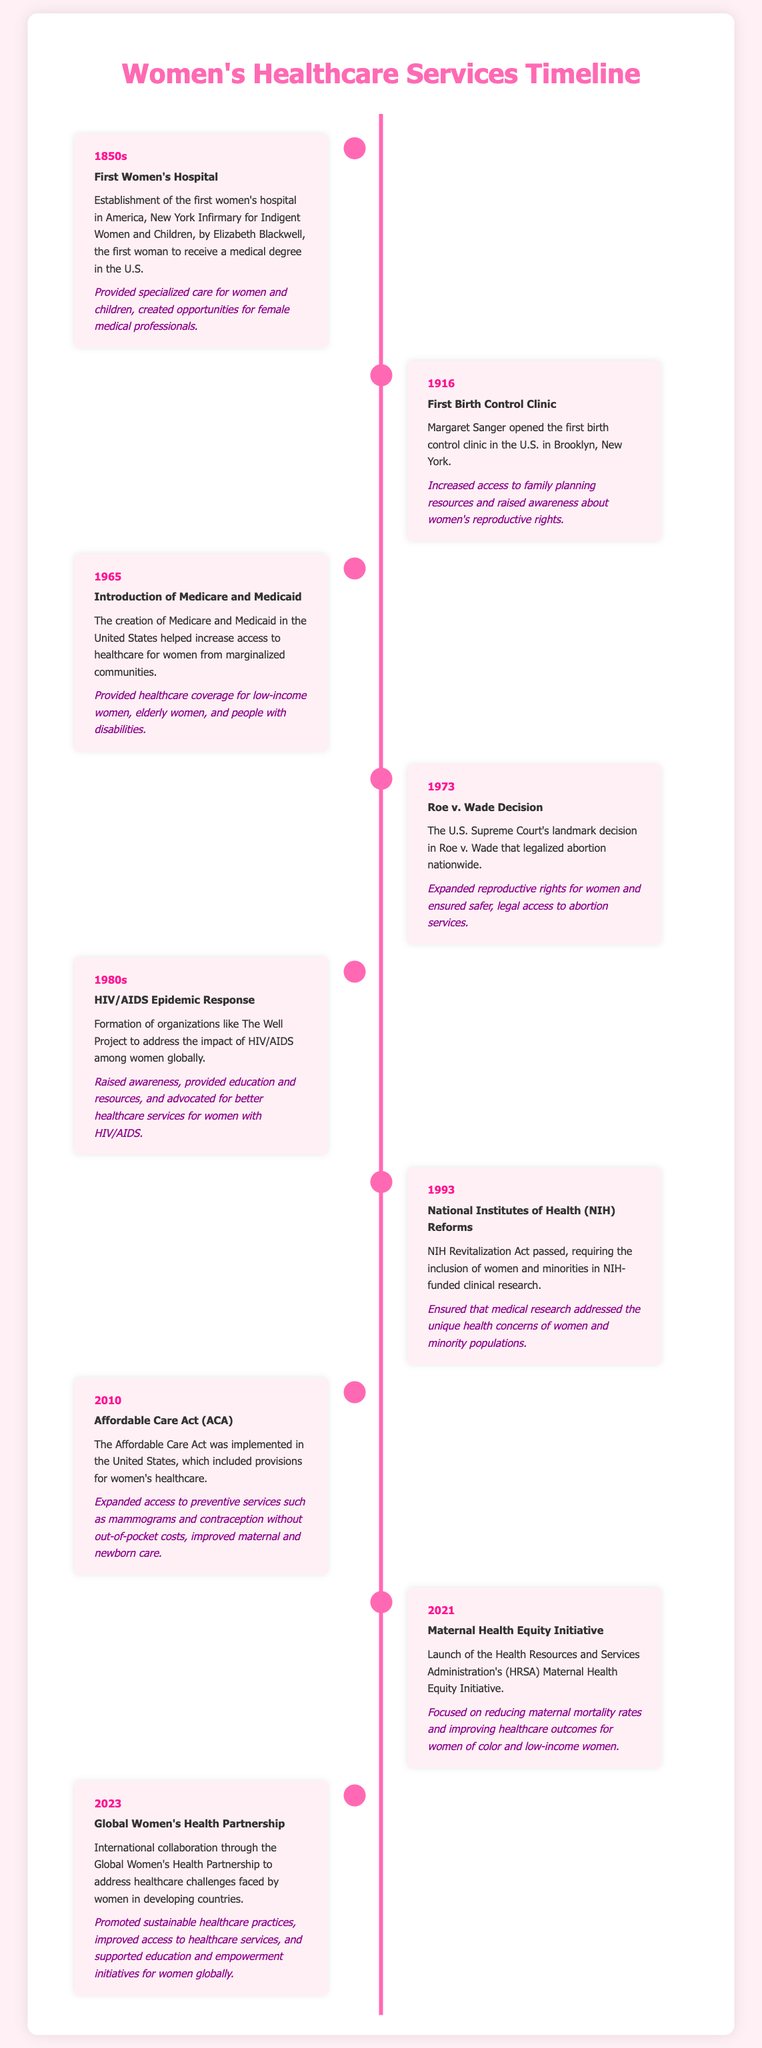what year was the first women's hospital established? The document states that the first women's hospital was established in the 1850s.
Answer: 1850s who opened the first birth control clinic in the U.S.? The timeline mentions Margaret Sanger as the person who opened the first birth control clinic.
Answer: Margaret Sanger what significant healthcare program was introduced in 1965? The entry for 1965 indicates that Medicare and Medicaid were introduced during that year.
Answer: Medicare and Medicaid what landmark decision was made in 1973 regarding women's rights? The document highlights the Roe v. Wade decision made in 1973 that legalized abortion nationwide.
Answer: Roe v. Wade what organization was formed in the 1980s to address HIV/AIDS among women? The document notes that The Well Project was formed in the 1980s to respond to the HIV/AIDS epidemic.
Answer: The Well Project how many years after the 1965 introduction of Medicare and Medicaid was the Affordable Care Act implemented? The Affordable Care Act was implemented in 2010, which is 45 years after 1965.
Answer: 45 years what was the focus of the Maternal Health Equity Initiative launched in 2021? The document states the focus was to reduce maternal mortality rates and improve healthcare outcomes for women of color and low-income women.
Answer: Reduce maternal mortality rates which event highlights international collaboration in women's healthcare in 2023? The Global Women's Health Partnership, as indicated in the timeline, is the event that showcases international collaboration in 2023.
Answer: Global Women's Health Partnership what service did the Affordable Care Act expand access to without out-of-pocket costs? The timeline mentions that the ACA expanded access to preventive services such as mammograms.
Answer: Preventive services 